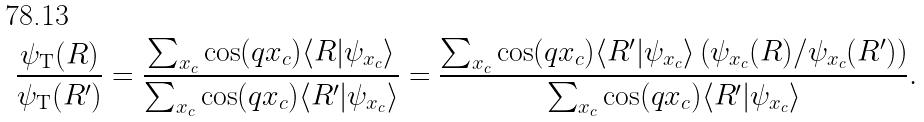<formula> <loc_0><loc_0><loc_500><loc_500>\frac { \psi _ { \text {T} } ( R ) } { \psi _ { \text {T} } ( R ^ { \prime } ) } = \frac { \sum _ { x _ { c } } \cos ( q x _ { c } ) \langle R | \psi _ { x _ { c } } \rangle } { \sum _ { x _ { c } } \cos ( q x _ { c } ) \langle R ^ { \prime } | \psi _ { x _ { c } } \rangle } = \frac { \sum _ { x _ { c } } \cos ( q x _ { c } ) \langle R ^ { \prime } | \psi _ { x _ { c } } \rangle \left ( \psi _ { x _ { c } } ( R ) / \psi _ { x _ { c } } ( R ^ { \prime } ) \right ) } { \sum _ { x _ { c } } \cos ( q x _ { c } ) \langle R ^ { \prime } | \psi _ { x _ { c } } \rangle } .</formula> 